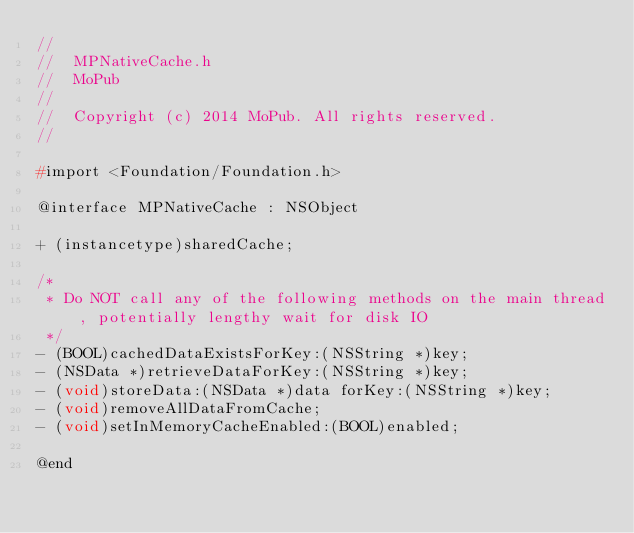Convert code to text. <code><loc_0><loc_0><loc_500><loc_500><_C_>//
//  MPNativeCache.h
//  MoPub
//
//  Copyright (c) 2014 MoPub. All rights reserved.
//

#import <Foundation/Foundation.h>

@interface MPNativeCache : NSObject

+ (instancetype)sharedCache;

/*
 * Do NOT call any of the following methods on the main thread, potentially lengthy wait for disk IO
 */
- (BOOL)cachedDataExistsForKey:(NSString *)key;
- (NSData *)retrieveDataForKey:(NSString *)key;
- (void)storeData:(NSData *)data forKey:(NSString *)key;
- (void)removeAllDataFromCache;
- (void)setInMemoryCacheEnabled:(BOOL)enabled;

@end
</code> 